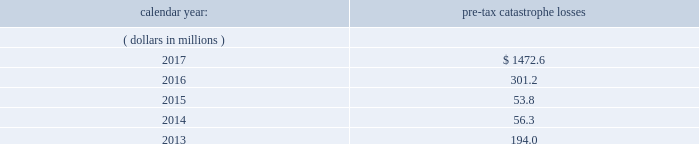Item 1a .
Risk factors in addition to the other information provided in this report , the following risk factors should be considered when evaluating an investment in our securities .
If the circumstances contemplated by the individual risk factors materialize , our business , financial condition and results of operations could be materially and adversely affected and the trading price of our common shares could decline significantly .
Risks relating to our business fluctuations in the financial markets could result in investment losses .
Prolonged and severe disruptions in the overall public debt and equity markets , such as occurred during 2008 , could result in significant realized and unrealized losses in our investment portfolio .
Although financial markets have significantly improved since 2008 , they could deteriorate in the future .
There could also be disruption in individual market sectors , such as occurred in the energy sector in recent years .
Such declines in the financial markets could result in significant realized and unrealized losses on investments and could have a material adverse impact on our results of operations , equity , business and insurer financial strength and debt ratings .
Our results could be adversely affected by catastrophic events .
We are exposed to unpredictable catastrophic events , including weather-related and other natural catastrophes , as well as acts of terrorism .
Any material reduction in our operating results caused by the occurrence of one or more catastrophes could inhibit our ability to pay dividends or to meet our interest and principal payment obligations .
By way of illustration , during the past five calendar years , pre-tax catastrophe losses , net of reinsurance , were as follows: .
Our losses from future catastrophic events could exceed our projections .
We use projections of possible losses from future catastrophic events of varying types and magnitudes as a strategic underwriting tool .
We use these loss projections to estimate our potential catastrophe losses in certain geographic areas and decide on the placement of retrocessional coverage or other actions to limit the extent of potential losses in a given geographic area .
These loss projections are approximations , reliant on a mix of quantitative and qualitative processes , and actual losses may exceed the projections by a material amount , resulting in a material adverse effect on our financial condition and results of operations. .
What was the change pre-tax catastrophe losses from 2016 to 2017 in thousands? 
Computations: (1472.6 - 301.2)
Answer: 1171.4. Item 1a .
Risk factors in addition to the other information provided in this report , the following risk factors should be considered when evaluating an investment in our securities .
If the circumstances contemplated by the individual risk factors materialize , our business , financial condition and results of operations could be materially and adversely affected and the trading price of our common shares could decline significantly .
Risks relating to our business fluctuations in the financial markets could result in investment losses .
Prolonged and severe disruptions in the overall public debt and equity markets , such as occurred during 2008 , could result in significant realized and unrealized losses in our investment portfolio .
Although financial markets have significantly improved since 2008 , they could deteriorate in the future .
There could also be disruption in individual market sectors , such as occurred in the energy sector in recent years .
Such declines in the financial markets could result in significant realized and unrealized losses on investments and could have a material adverse impact on our results of operations , equity , business and insurer financial strength and debt ratings .
Our results could be adversely affected by catastrophic events .
We are exposed to unpredictable catastrophic events , including weather-related and other natural catastrophes , as well as acts of terrorism .
Any material reduction in our operating results caused by the occurrence of one or more catastrophes could inhibit our ability to pay dividends or to meet our interest and principal payment obligations .
By way of illustration , during the past five calendar years , pre-tax catastrophe losses , net of reinsurance , were as follows: .
Our losses from future catastrophic events could exceed our projections .
We use projections of possible losses from future catastrophic events of varying types and magnitudes as a strategic underwriting tool .
We use these loss projections to estimate our potential catastrophe losses in certain geographic areas and decide on the placement of retrocessional coverage or other actions to limit the extent of potential losses in a given geographic area .
These loss projections are approximations , reliant on a mix of quantitative and qualitative processes , and actual losses may exceed the projections by a material amount , resulting in a material adverse effect on our financial condition and results of operations. .
What was the average pre-tax catastrophe losses from 2013 to 2017? 
Computations: ((((((194.0 + 56.3) + 53.8) + 301.2) + 1472.6) + 5) / 2)
Answer: 1041.45. 